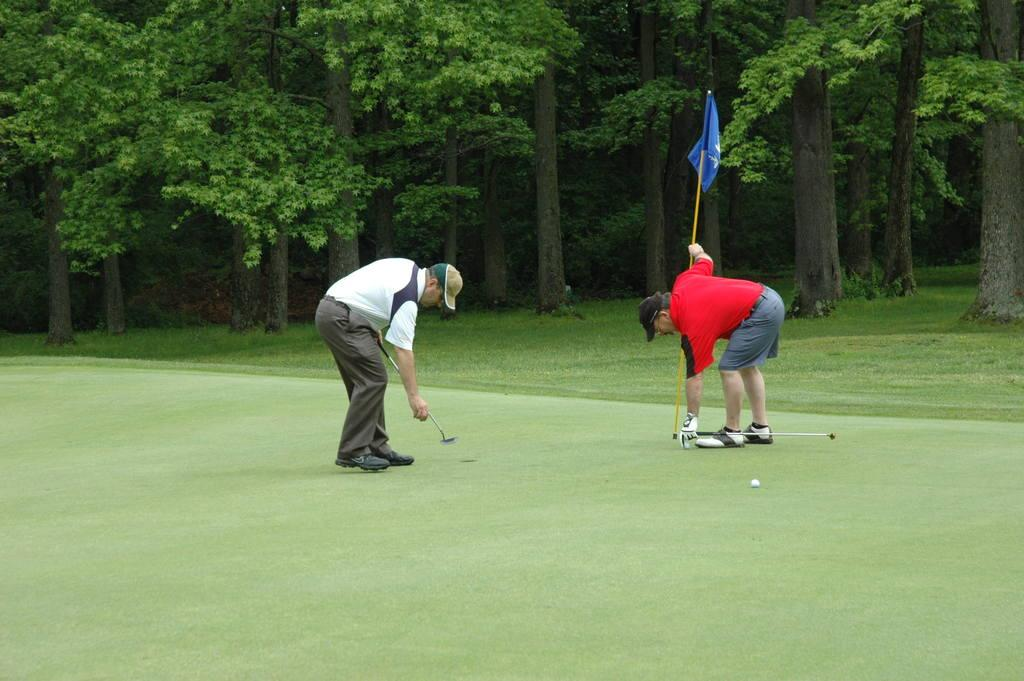What is the possible location of the image? The image might be taken in a golf court. How many people are in the image? There are two persons in the image. What can be seen in the image that might indicate a game or sport? There is a flag, a ball, and a bat in the image. Are there any other objects in the image besides the ones mentioned? Yes, there are other objects in the image. What can be seen in the background of the image? There are trees in the background of the image. What type of growth can be seen on the wall in the image? There is no wall present in the image, so there cannot be any growth on it. 